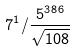Convert formula to latex. <formula><loc_0><loc_0><loc_500><loc_500>7 ^ { 1 } / \frac { 5 ^ { 3 8 6 } } { \sqrt { 1 0 8 } }</formula> 